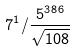Convert formula to latex. <formula><loc_0><loc_0><loc_500><loc_500>7 ^ { 1 } / \frac { 5 ^ { 3 8 6 } } { \sqrt { 1 0 8 } }</formula> 